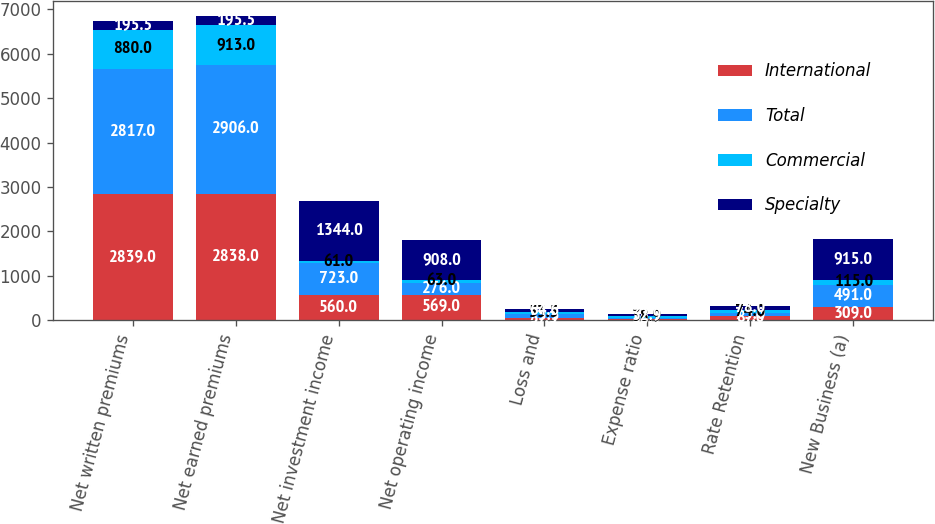<chart> <loc_0><loc_0><loc_500><loc_500><stacked_bar_chart><ecel><fcel>Net written premiums<fcel>Net earned premiums<fcel>Net investment income<fcel>Net operating income<fcel>Loss and<fcel>Expense ratio<fcel>Rate Retention<fcel>New Business (a)<nl><fcel>International<fcel>2839<fcel>2838<fcel>560<fcel>569<fcel>57.3<fcel>30.1<fcel>87<fcel>309<nl><fcel>Total<fcel>2817<fcel>2906<fcel>723<fcel>276<fcel>75.3<fcel>33.7<fcel>73<fcel>491<nl><fcel>Commercial<fcel>880<fcel>913<fcel>61<fcel>63<fcel>53.5<fcel>38.9<fcel>74<fcel>115<nl><fcel>Specialty<fcel>195.5<fcel>195.5<fcel>1344<fcel>908<fcel>64.6<fcel>32.9<fcel>78<fcel>915<nl></chart> 